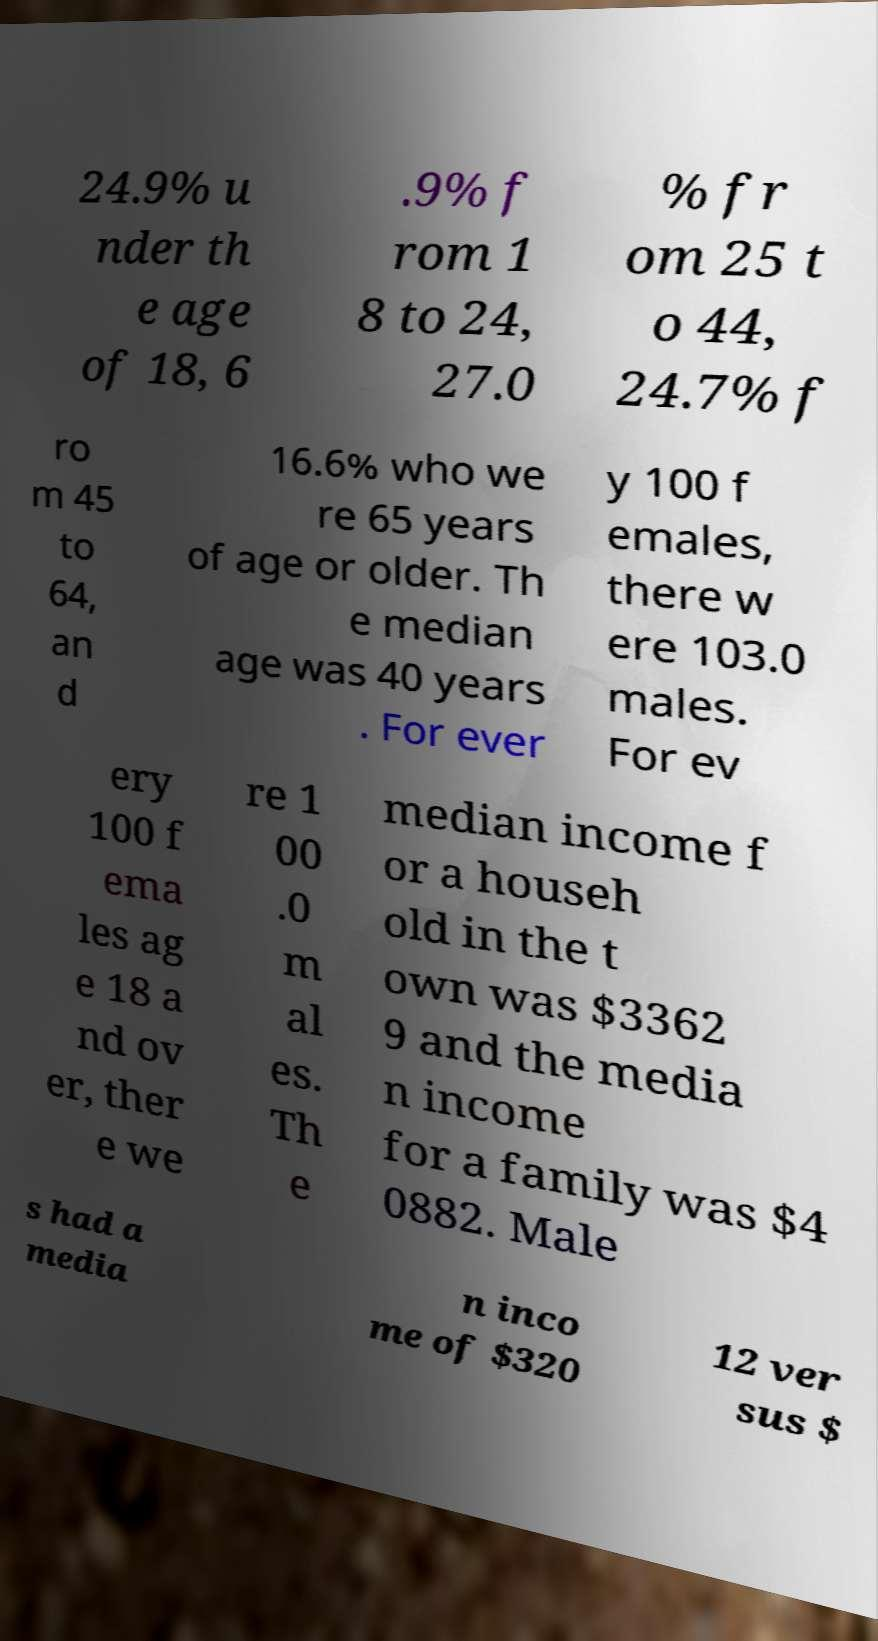Please read and relay the text visible in this image. What does it say? 24.9% u nder th e age of 18, 6 .9% f rom 1 8 to 24, 27.0 % fr om 25 t o 44, 24.7% f ro m 45 to 64, an d 16.6% who we re 65 years of age or older. Th e median age was 40 years . For ever y 100 f emales, there w ere 103.0 males. For ev ery 100 f ema les ag e 18 a nd ov er, ther e we re 1 00 .0 m al es. Th e median income f or a househ old in the t own was $3362 9 and the media n income for a family was $4 0882. Male s had a media n inco me of $320 12 ver sus $ 